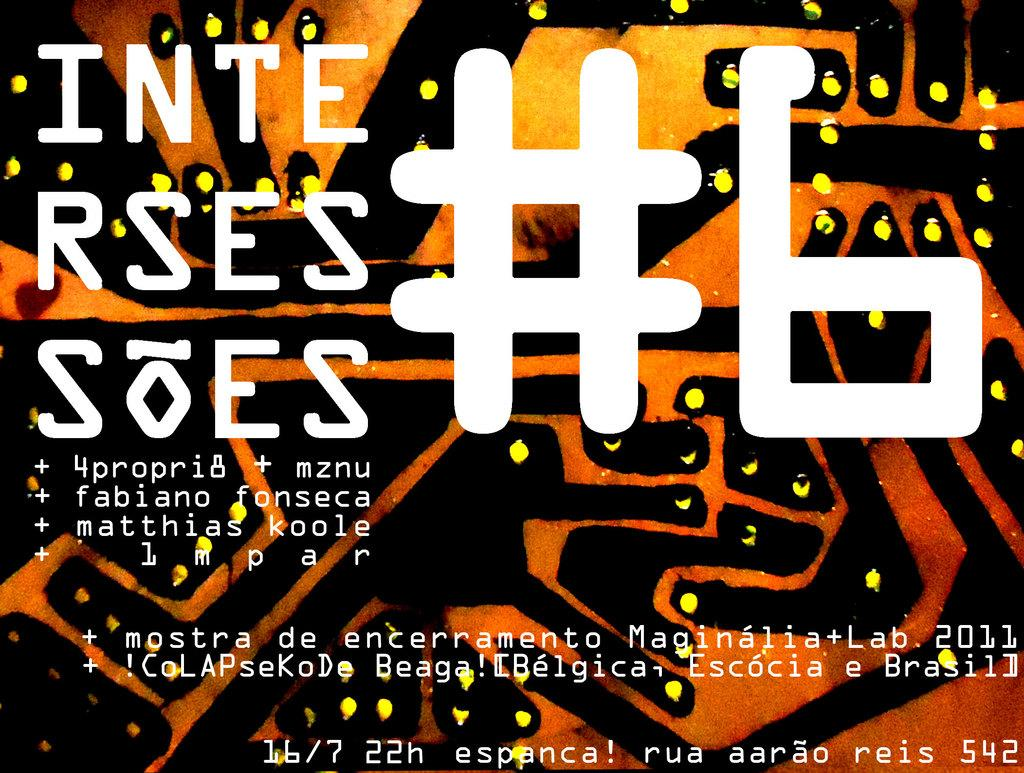<image>
Create a compact narrative representing the image presented. A poster advertises an event called "Inte Rses Soes." 